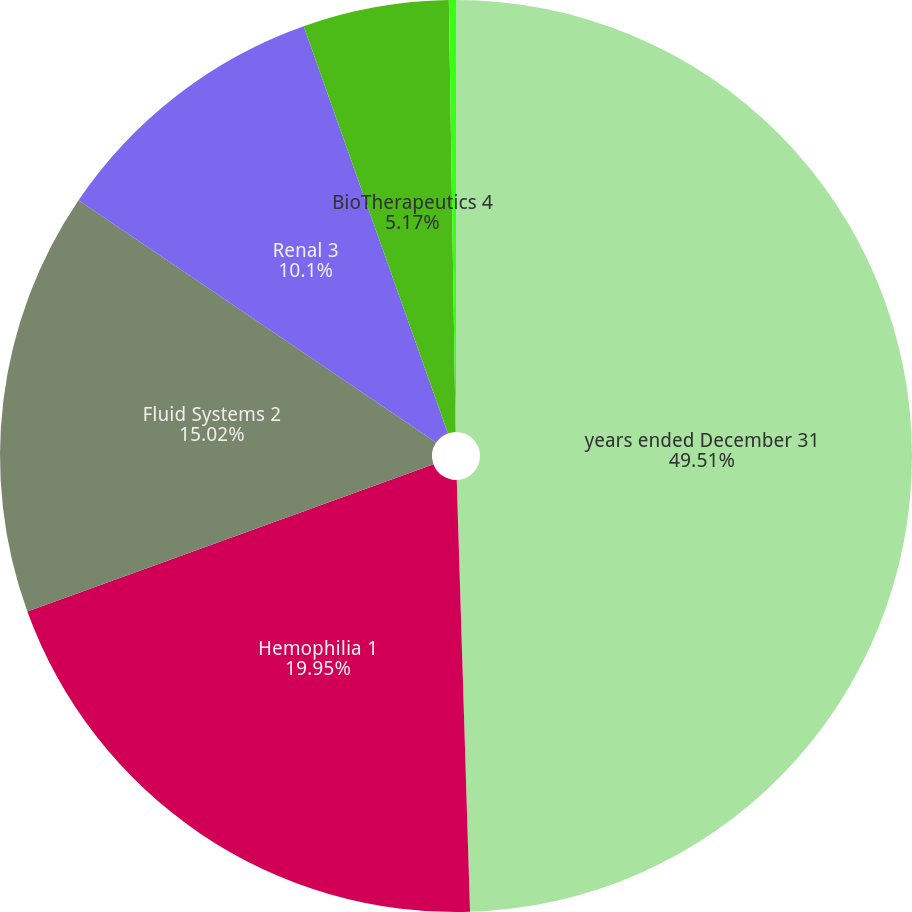Convert chart to OTSL. <chart><loc_0><loc_0><loc_500><loc_500><pie_chart><fcel>years ended December 31<fcel>Hemophilia 1<fcel>Fluid Systems 2<fcel>Renal 3<fcel>BioTherapeutics 4<fcel>Specialty Pharmaceuticals 5<nl><fcel>49.51%<fcel>19.95%<fcel>15.02%<fcel>10.1%<fcel>5.17%<fcel>0.25%<nl></chart> 